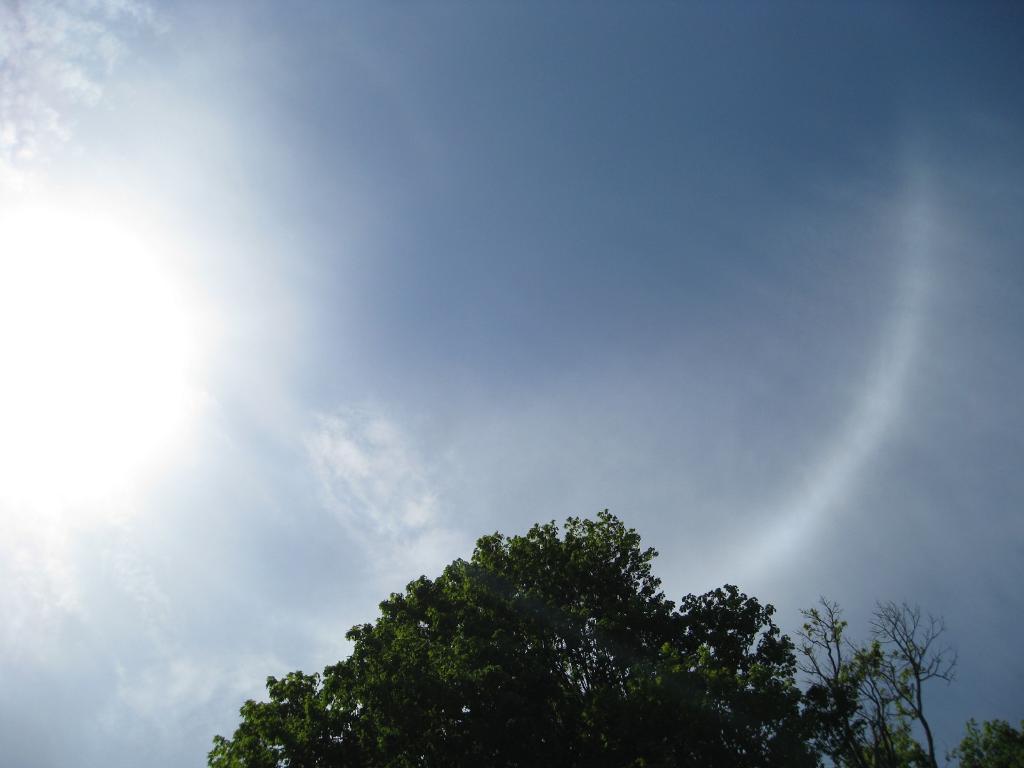In one or two sentences, can you explain what this image depicts? This is tree and a blue color sky. 